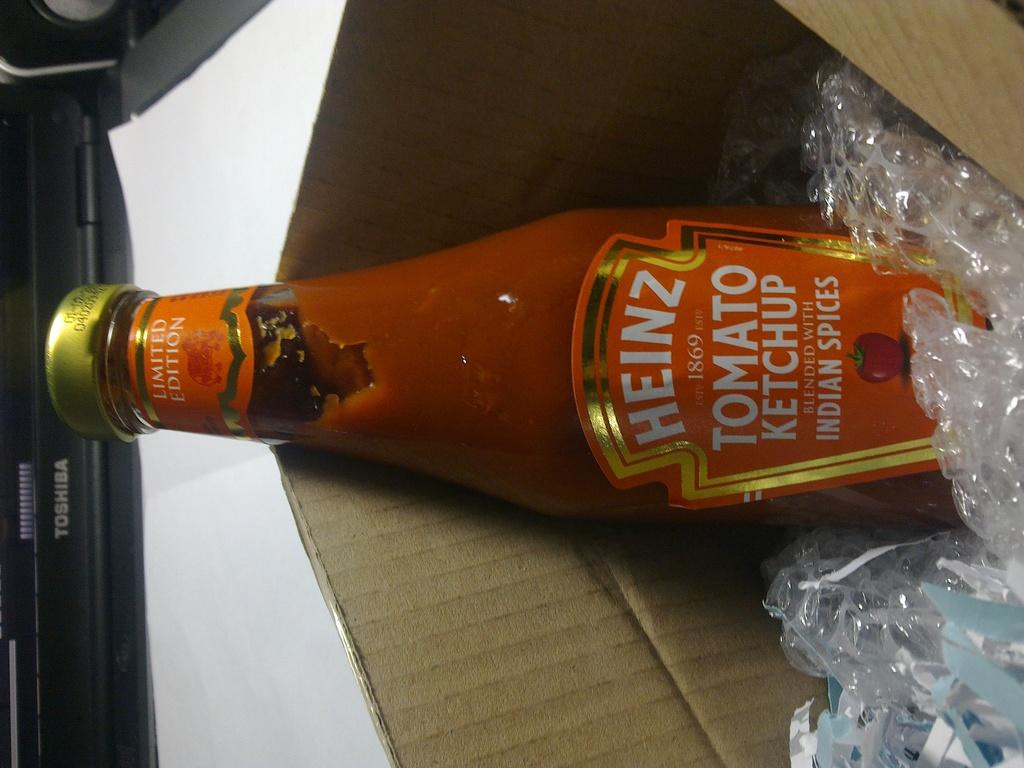What spices is the ketchup flavoured with?
Keep it short and to the point. Indian. 